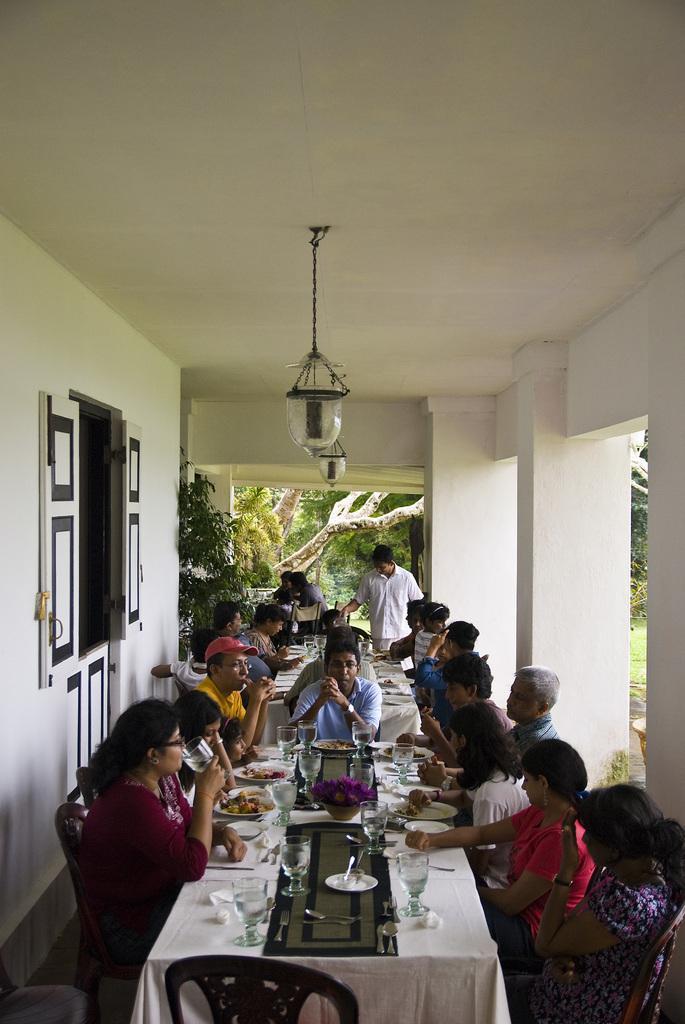In one or two sentences, can you explain what this image depicts? In the image we can see group of people were sitting on the chair around the table having their food. And in the center we can see one man is standing. On table they were food items,coming to the background there is a pillar and some trees. 